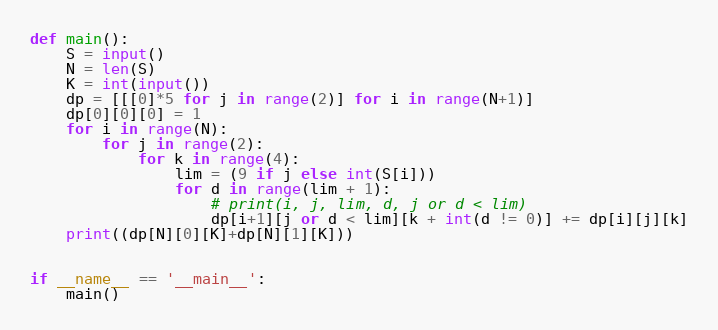Convert code to text. <code><loc_0><loc_0><loc_500><loc_500><_Python_>def main():
    S = input()
    N = len(S)
    K = int(input())
    dp = [[[0]*5 for j in range(2)] for i in range(N+1)]
    dp[0][0][0] = 1
    for i in range(N):
        for j in range(2):
            for k in range(4):
                lim = (9 if j else int(S[i]))
                for d in range(lim + 1):
                    # print(i, j, lim, d, j or d < lim)
                    dp[i+1][j or d < lim][k + int(d != 0)] += dp[i][j][k]
    print((dp[N][0][K]+dp[N][1][K]))


if __name__ == '__main__':
    main()
</code> 